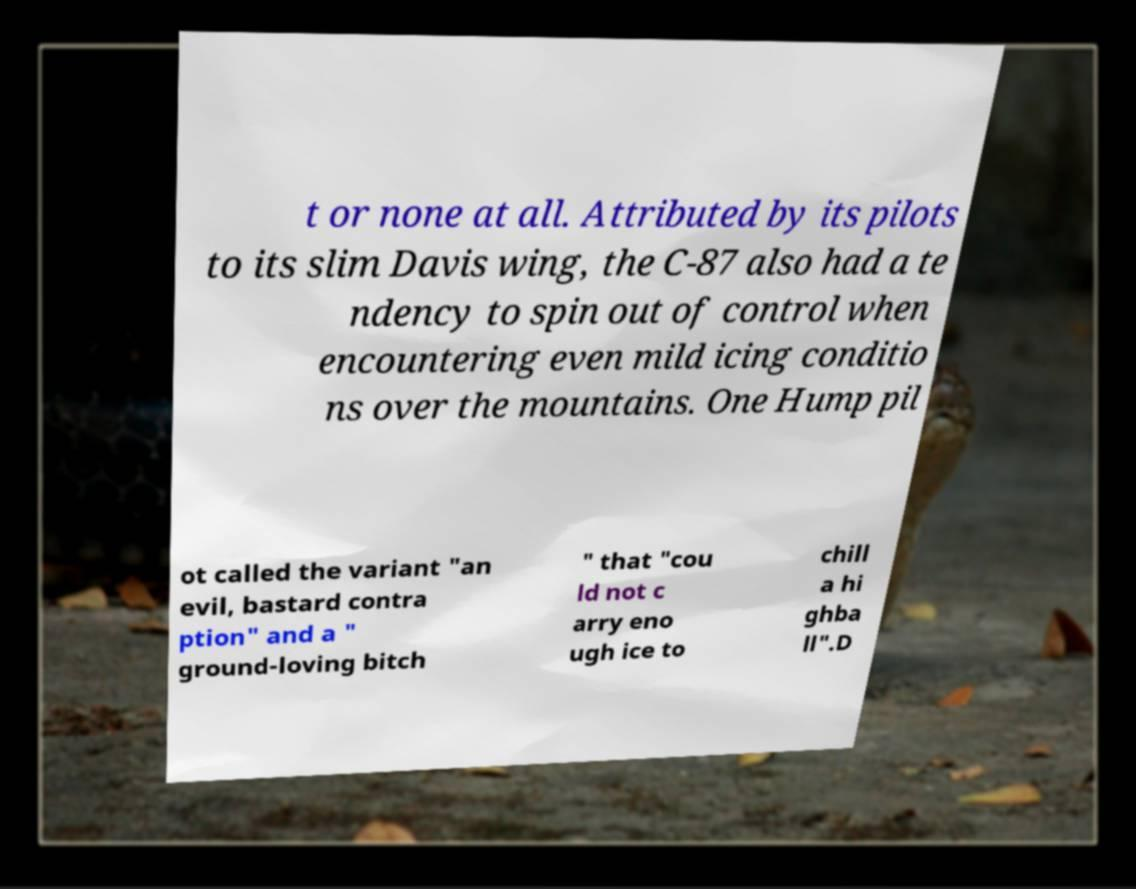Please identify and transcribe the text found in this image. t or none at all. Attributed by its pilots to its slim Davis wing, the C-87 also had a te ndency to spin out of control when encountering even mild icing conditio ns over the mountains. One Hump pil ot called the variant "an evil, bastard contra ption" and a " ground-loving bitch " that "cou ld not c arry eno ugh ice to chill a hi ghba ll".D 